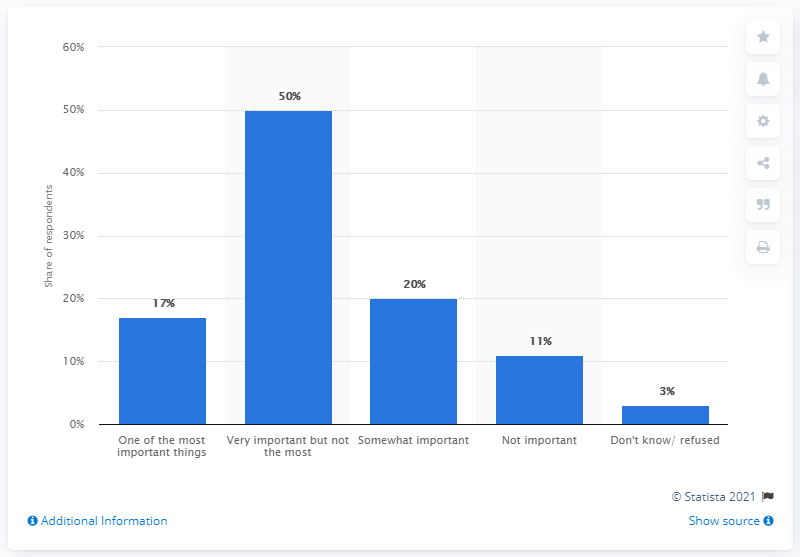Identify some key points in this picture. The important opinions are significantly more than the unimportant opinions. I do not know or refuse to answer the question about the 3% bar. 